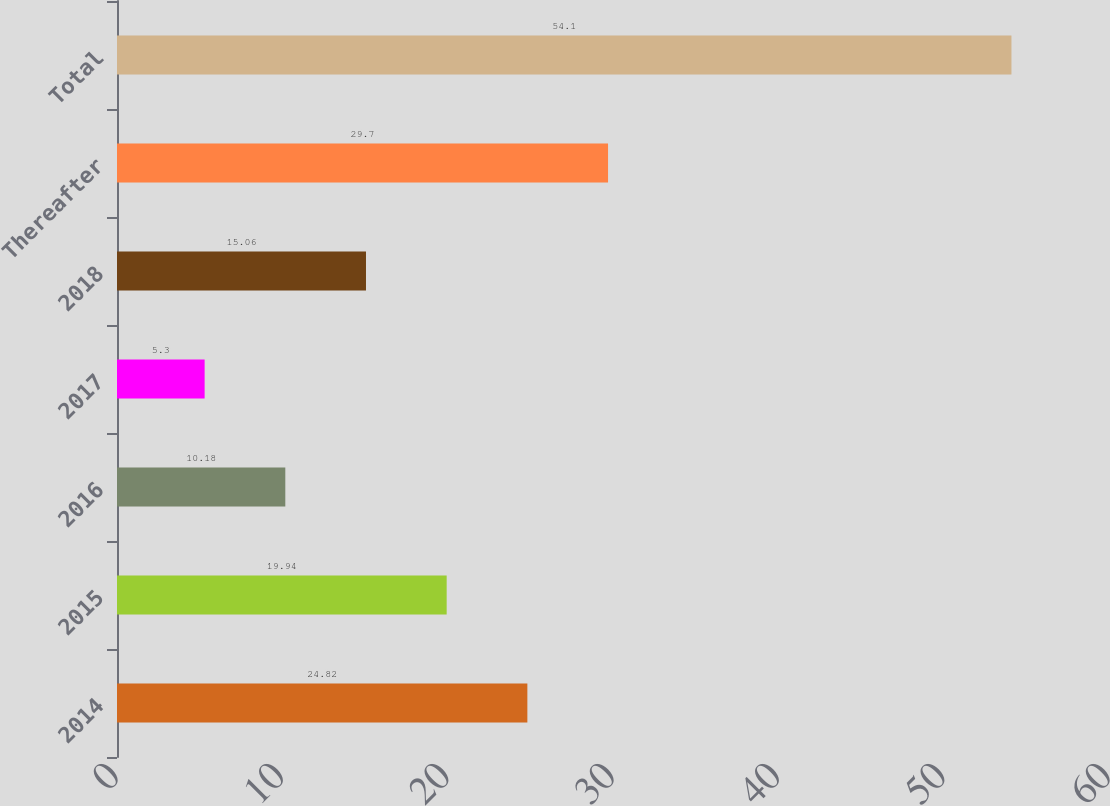<chart> <loc_0><loc_0><loc_500><loc_500><bar_chart><fcel>2014<fcel>2015<fcel>2016<fcel>2017<fcel>2018<fcel>Thereafter<fcel>Total<nl><fcel>24.82<fcel>19.94<fcel>10.18<fcel>5.3<fcel>15.06<fcel>29.7<fcel>54.1<nl></chart> 